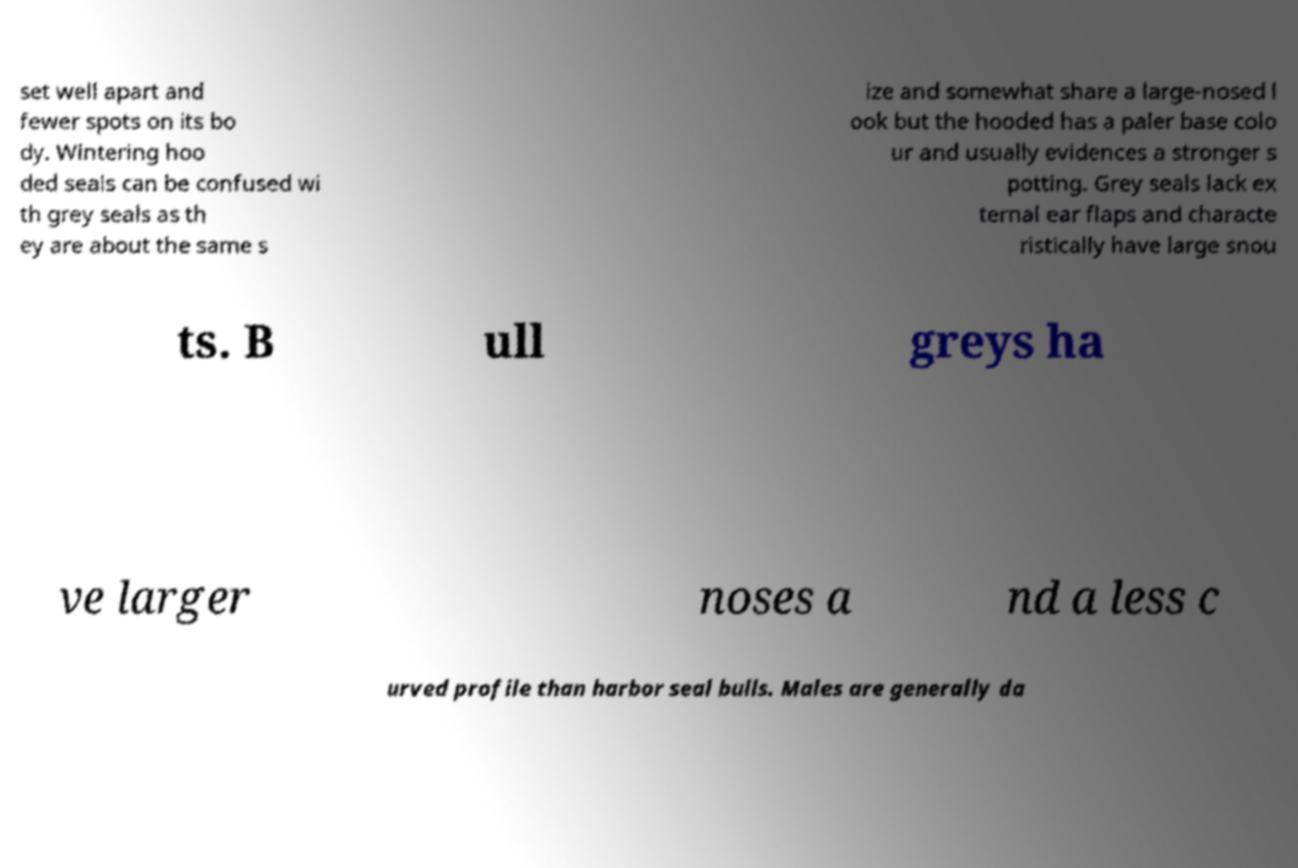For documentation purposes, I need the text within this image transcribed. Could you provide that? set well apart and fewer spots on its bo dy. Wintering hoo ded seals can be confused wi th grey seals as th ey are about the same s ize and somewhat share a large-nosed l ook but the hooded has a paler base colo ur and usually evidences a stronger s potting. Grey seals lack ex ternal ear flaps and characte ristically have large snou ts. B ull greys ha ve larger noses a nd a less c urved profile than harbor seal bulls. Males are generally da 